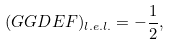Convert formula to latex. <formula><loc_0><loc_0><loc_500><loc_500>( G G D E F ) _ { l . e . l . } = - \frac { 1 } { 2 } ,</formula> 